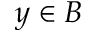Convert formula to latex. <formula><loc_0><loc_0><loc_500><loc_500>y \in B</formula> 